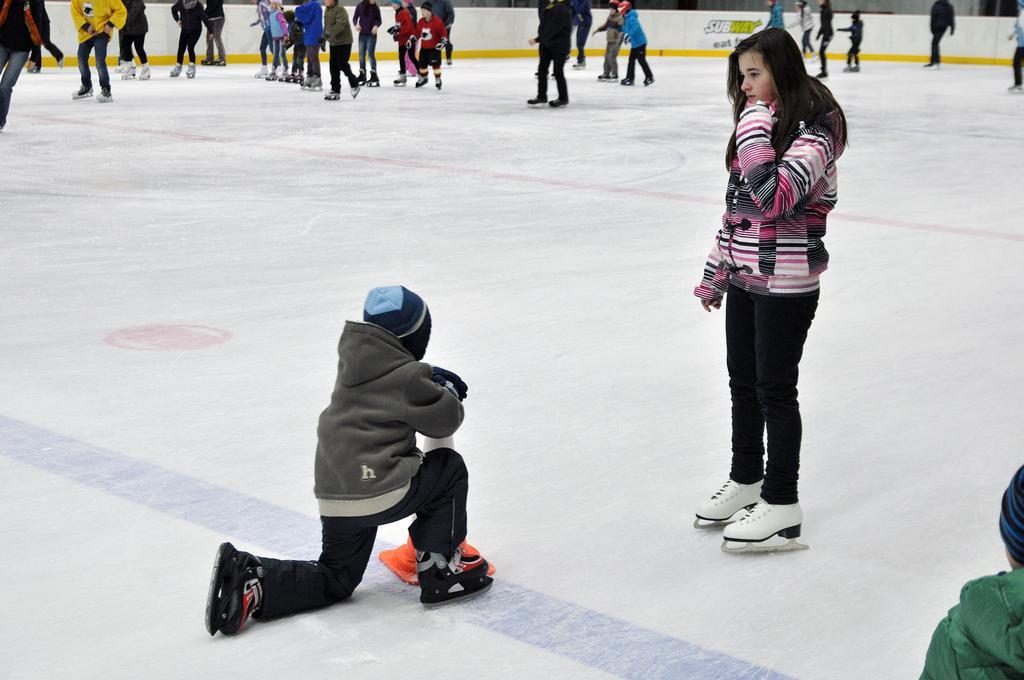Please provide a concise description of this image. This picture describes about group of people, few are skating on the ice with the help of shoes, in the middle of the image we can see a road divider cone. 